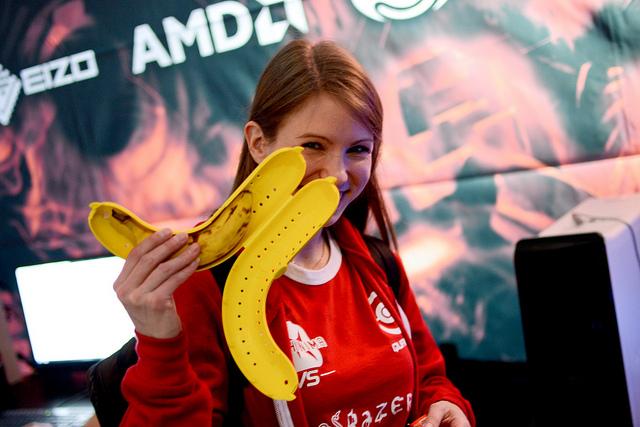What is inside the yellow plastic object?
Short answer required. Banana. What attitude is this person expressing?
Write a very short answer. Happy. What fruit is the woman holding?
Answer briefly. Banana. 